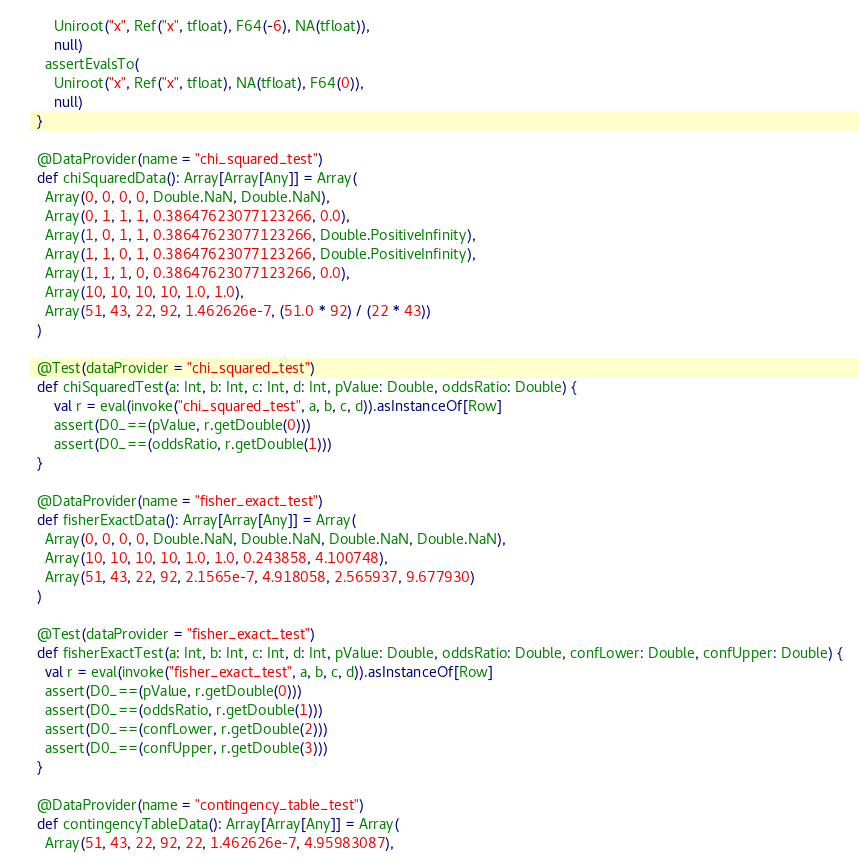Convert code to text. <code><loc_0><loc_0><loc_500><loc_500><_Scala_>      Uniroot("x", Ref("x", tfloat), F64(-6), NA(tfloat)),
      null)
    assertEvalsTo(
      Uniroot("x", Ref("x", tfloat), NA(tfloat), F64(0)),
      null)
  }

  @DataProvider(name = "chi_squared_test")
  def chiSquaredData(): Array[Array[Any]] = Array(
    Array(0, 0, 0, 0, Double.NaN, Double.NaN),
    Array(0, 1, 1, 1, 0.38647623077123266, 0.0),
    Array(1, 0, 1, 1, 0.38647623077123266, Double.PositiveInfinity),
    Array(1, 1, 0, 1, 0.38647623077123266, Double.PositiveInfinity),
    Array(1, 1, 1, 0, 0.38647623077123266, 0.0),
    Array(10, 10, 10, 10, 1.0, 1.0),
    Array(51, 43, 22, 92, 1.462626e-7, (51.0 * 92) / (22 * 43))
  )

  @Test(dataProvider = "chi_squared_test")
  def chiSquaredTest(a: Int, b: Int, c: Int, d: Int, pValue: Double, oddsRatio: Double) {
      val r = eval(invoke("chi_squared_test", a, b, c, d)).asInstanceOf[Row]
      assert(D0_==(pValue, r.getDouble(0)))
      assert(D0_==(oddsRatio, r.getDouble(1)))
  }

  @DataProvider(name = "fisher_exact_test")
  def fisherExactData(): Array[Array[Any]] = Array(
    Array(0, 0, 0, 0, Double.NaN, Double.NaN, Double.NaN, Double.NaN),
    Array(10, 10, 10, 10, 1.0, 1.0, 0.243858, 4.100748),
    Array(51, 43, 22, 92, 2.1565e-7, 4.918058, 2.565937, 9.677930)
  )

  @Test(dataProvider = "fisher_exact_test")
  def fisherExactTest(a: Int, b: Int, c: Int, d: Int, pValue: Double, oddsRatio: Double, confLower: Double, confUpper: Double) {
    val r = eval(invoke("fisher_exact_test", a, b, c, d)).asInstanceOf[Row]
    assert(D0_==(pValue, r.getDouble(0)))
    assert(D0_==(oddsRatio, r.getDouble(1)))
    assert(D0_==(confLower, r.getDouble(2)))
    assert(D0_==(confUpper, r.getDouble(3)))
  }

  @DataProvider(name = "contingency_table_test")
  def contingencyTableData(): Array[Array[Any]] = Array(
    Array(51, 43, 22, 92, 22, 1.462626e-7, 4.95983087),</code> 